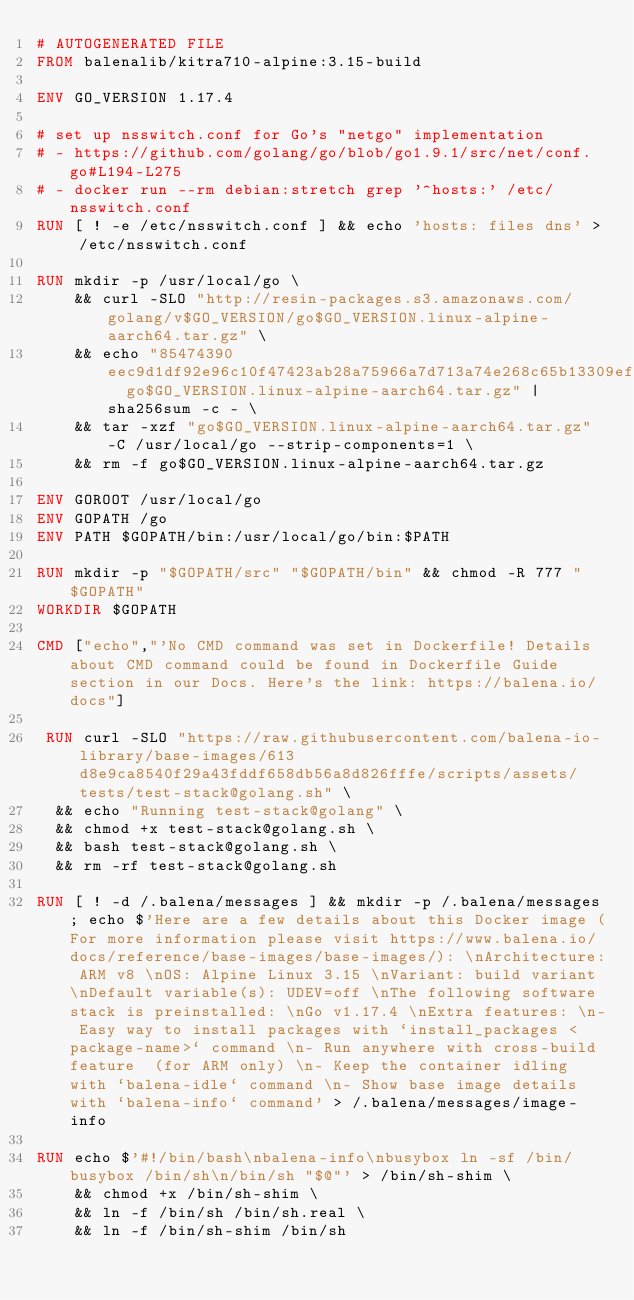<code> <loc_0><loc_0><loc_500><loc_500><_Dockerfile_># AUTOGENERATED FILE
FROM balenalib/kitra710-alpine:3.15-build

ENV GO_VERSION 1.17.4

# set up nsswitch.conf for Go's "netgo" implementation
# - https://github.com/golang/go/blob/go1.9.1/src/net/conf.go#L194-L275
# - docker run --rm debian:stretch grep '^hosts:' /etc/nsswitch.conf
RUN [ ! -e /etc/nsswitch.conf ] && echo 'hosts: files dns' > /etc/nsswitch.conf

RUN mkdir -p /usr/local/go \
	&& curl -SLO "http://resin-packages.s3.amazonaws.com/golang/v$GO_VERSION/go$GO_VERSION.linux-alpine-aarch64.tar.gz" \
	&& echo "85474390eec9d1df92e96c10f47423ab28a75966a7d713a74e268c65b13309ef  go$GO_VERSION.linux-alpine-aarch64.tar.gz" | sha256sum -c - \
	&& tar -xzf "go$GO_VERSION.linux-alpine-aarch64.tar.gz" -C /usr/local/go --strip-components=1 \
	&& rm -f go$GO_VERSION.linux-alpine-aarch64.tar.gz

ENV GOROOT /usr/local/go
ENV GOPATH /go
ENV PATH $GOPATH/bin:/usr/local/go/bin:$PATH

RUN mkdir -p "$GOPATH/src" "$GOPATH/bin" && chmod -R 777 "$GOPATH"
WORKDIR $GOPATH

CMD ["echo","'No CMD command was set in Dockerfile! Details about CMD command could be found in Dockerfile Guide section in our Docs. Here's the link: https://balena.io/docs"]

 RUN curl -SLO "https://raw.githubusercontent.com/balena-io-library/base-images/613d8e9ca8540f29a43fddf658db56a8d826fffe/scripts/assets/tests/test-stack@golang.sh" \
  && echo "Running test-stack@golang" \
  && chmod +x test-stack@golang.sh \
  && bash test-stack@golang.sh \
  && rm -rf test-stack@golang.sh 

RUN [ ! -d /.balena/messages ] && mkdir -p /.balena/messages; echo $'Here are a few details about this Docker image (For more information please visit https://www.balena.io/docs/reference/base-images/base-images/): \nArchitecture: ARM v8 \nOS: Alpine Linux 3.15 \nVariant: build variant \nDefault variable(s): UDEV=off \nThe following software stack is preinstalled: \nGo v1.17.4 \nExtra features: \n- Easy way to install packages with `install_packages <package-name>` command \n- Run anywhere with cross-build feature  (for ARM only) \n- Keep the container idling with `balena-idle` command \n- Show base image details with `balena-info` command' > /.balena/messages/image-info

RUN echo $'#!/bin/bash\nbalena-info\nbusybox ln -sf /bin/busybox /bin/sh\n/bin/sh "$@"' > /bin/sh-shim \
	&& chmod +x /bin/sh-shim \
	&& ln -f /bin/sh /bin/sh.real \
	&& ln -f /bin/sh-shim /bin/sh</code> 